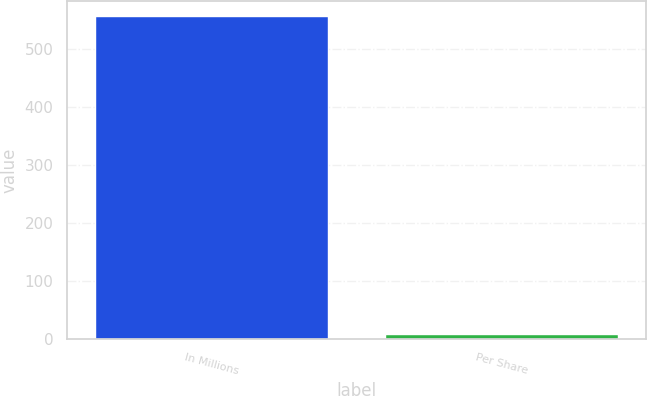Convert chart. <chart><loc_0><loc_0><loc_500><loc_500><bar_chart><fcel>In Millions<fcel>Per Share<nl><fcel>554.5<fcel>6.02<nl></chart> 